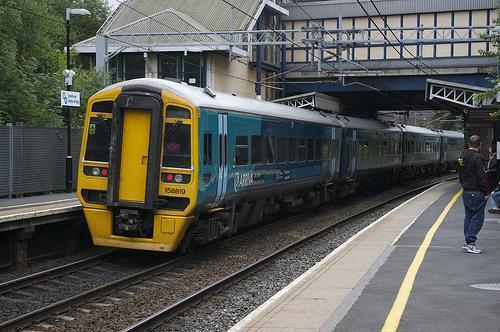How many people are on the platform waiting?
Give a very brief answer. 2. 